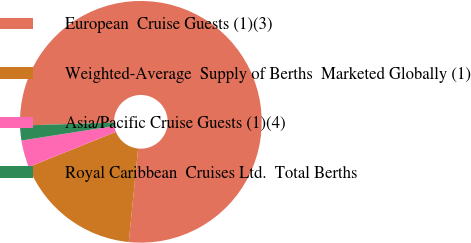Convert chart. <chart><loc_0><loc_0><loc_500><loc_500><pie_chart><fcel>European  Cruise Guests (1)(3)<fcel>Weighted-Average  Supply of Berths  Marketed Globally (1)<fcel>Asia/Pacific Cruise Guests (1)(4)<fcel>Royal Caribbean  Cruises Ltd.  Total Berths<nl><fcel>77.09%<fcel>17.31%<fcel>3.62%<fcel>1.98%<nl></chart> 